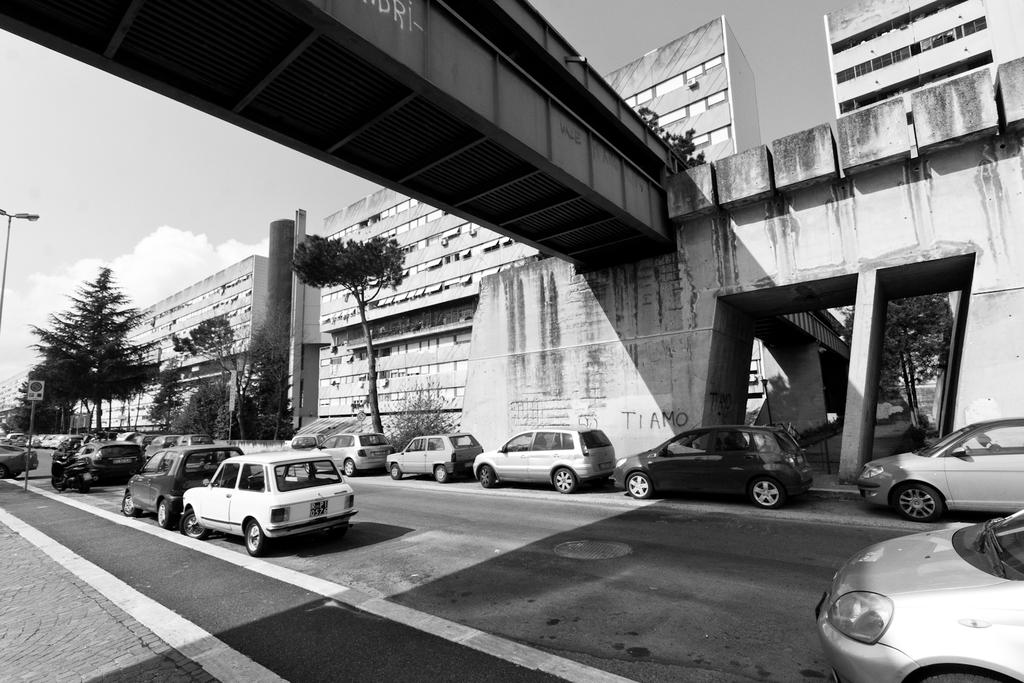What can be seen on the road in the image? There are vehicles on the road in the image. What else is visible in the image besides the vehicles? There are poles visible in the image. What type of structure is present in the image? There is a bridge in the image. What type of cloth is draped over the bridge in the image? There is no cloth present on the bridge in the image. How many stars can be seen in the sky in the image? The image does not show the sky, so it is not possible to determine how many stars are visible. 